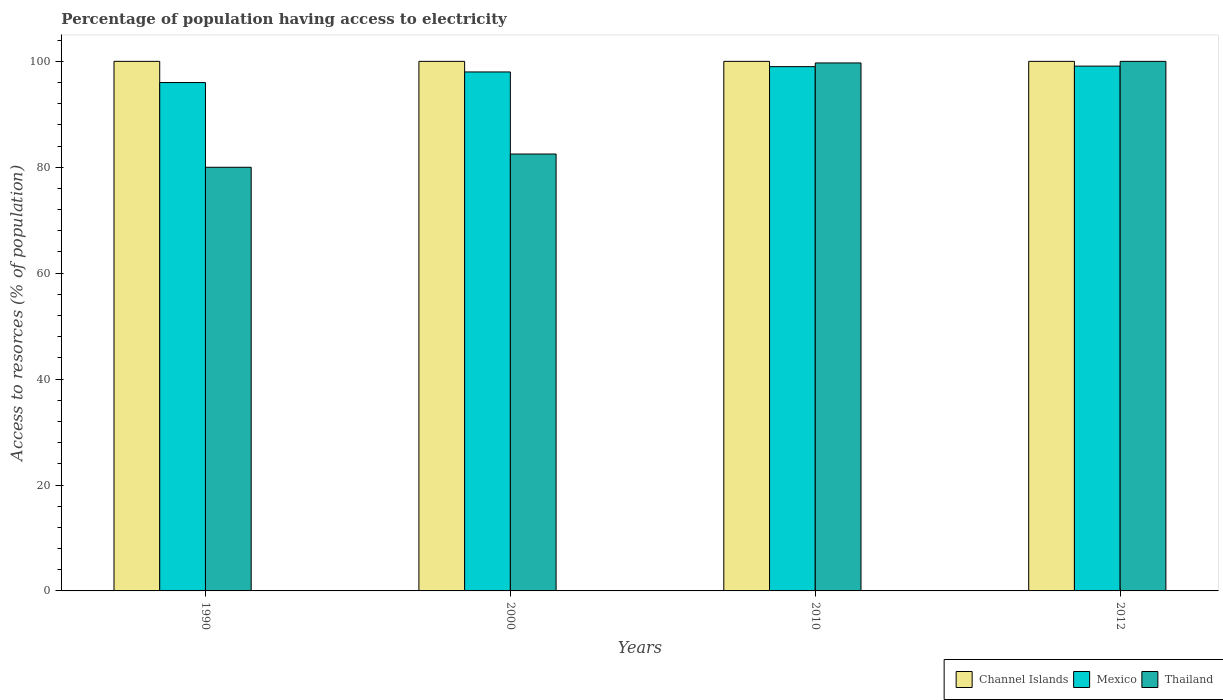Are the number of bars per tick equal to the number of legend labels?
Offer a very short reply. Yes. Are the number of bars on each tick of the X-axis equal?
Offer a very short reply. Yes. How many bars are there on the 1st tick from the left?
Your answer should be very brief. 3. What is the label of the 4th group of bars from the left?
Offer a very short reply. 2012. What is the percentage of population having access to electricity in Mexico in 2000?
Your response must be concise. 98. Across all years, what is the maximum percentage of population having access to electricity in Thailand?
Offer a very short reply. 100. Across all years, what is the minimum percentage of population having access to electricity in Channel Islands?
Provide a short and direct response. 100. In which year was the percentage of population having access to electricity in Mexico maximum?
Your answer should be very brief. 2012. In which year was the percentage of population having access to electricity in Channel Islands minimum?
Provide a short and direct response. 1990. What is the total percentage of population having access to electricity in Mexico in the graph?
Make the answer very short. 392.1. What is the difference between the percentage of population having access to electricity in Channel Islands in 2000 and the percentage of population having access to electricity in Thailand in 1990?
Offer a very short reply. 20. In the year 2010, what is the difference between the percentage of population having access to electricity in Channel Islands and percentage of population having access to electricity in Thailand?
Ensure brevity in your answer.  0.3. What is the ratio of the percentage of population having access to electricity in Thailand in 1990 to that in 2000?
Ensure brevity in your answer.  0.97. Is the percentage of population having access to electricity in Thailand in 1990 less than that in 2000?
Your answer should be very brief. Yes. Is the difference between the percentage of population having access to electricity in Channel Islands in 1990 and 2012 greater than the difference between the percentage of population having access to electricity in Thailand in 1990 and 2012?
Offer a terse response. Yes. What is the difference between the highest and the second highest percentage of population having access to electricity in Channel Islands?
Offer a terse response. 0. What is the difference between the highest and the lowest percentage of population having access to electricity in Channel Islands?
Your answer should be compact. 0. In how many years, is the percentage of population having access to electricity in Thailand greater than the average percentage of population having access to electricity in Thailand taken over all years?
Provide a short and direct response. 2. What does the 3rd bar from the left in 2000 represents?
Make the answer very short. Thailand. What does the 3rd bar from the right in 2000 represents?
Offer a terse response. Channel Islands. How many years are there in the graph?
Your answer should be compact. 4. What is the difference between two consecutive major ticks on the Y-axis?
Your response must be concise. 20. Are the values on the major ticks of Y-axis written in scientific E-notation?
Your response must be concise. No. Where does the legend appear in the graph?
Make the answer very short. Bottom right. How many legend labels are there?
Ensure brevity in your answer.  3. What is the title of the graph?
Make the answer very short. Percentage of population having access to electricity. What is the label or title of the X-axis?
Offer a terse response. Years. What is the label or title of the Y-axis?
Keep it short and to the point. Access to resorces (% of population). What is the Access to resorces (% of population) in Channel Islands in 1990?
Provide a succinct answer. 100. What is the Access to resorces (% of population) of Mexico in 1990?
Your answer should be very brief. 96. What is the Access to resorces (% of population) in Thailand in 1990?
Ensure brevity in your answer.  80. What is the Access to resorces (% of population) in Mexico in 2000?
Make the answer very short. 98. What is the Access to resorces (% of population) in Thailand in 2000?
Offer a very short reply. 82.5. What is the Access to resorces (% of population) in Channel Islands in 2010?
Keep it short and to the point. 100. What is the Access to resorces (% of population) of Thailand in 2010?
Give a very brief answer. 99.7. What is the Access to resorces (% of population) in Mexico in 2012?
Provide a short and direct response. 99.1. What is the Access to resorces (% of population) of Thailand in 2012?
Provide a short and direct response. 100. Across all years, what is the maximum Access to resorces (% of population) in Channel Islands?
Your answer should be compact. 100. Across all years, what is the maximum Access to resorces (% of population) in Mexico?
Your response must be concise. 99.1. Across all years, what is the minimum Access to resorces (% of population) of Channel Islands?
Provide a succinct answer. 100. Across all years, what is the minimum Access to resorces (% of population) of Mexico?
Offer a very short reply. 96. Across all years, what is the minimum Access to resorces (% of population) in Thailand?
Ensure brevity in your answer.  80. What is the total Access to resorces (% of population) in Mexico in the graph?
Provide a short and direct response. 392.1. What is the total Access to resorces (% of population) in Thailand in the graph?
Provide a succinct answer. 362.2. What is the difference between the Access to resorces (% of population) in Channel Islands in 1990 and that in 2000?
Your answer should be compact. 0. What is the difference between the Access to resorces (% of population) in Thailand in 1990 and that in 2000?
Keep it short and to the point. -2.5. What is the difference between the Access to resorces (% of population) in Thailand in 1990 and that in 2010?
Provide a succinct answer. -19.7. What is the difference between the Access to resorces (% of population) of Thailand in 1990 and that in 2012?
Your answer should be very brief. -20. What is the difference between the Access to resorces (% of population) of Thailand in 2000 and that in 2010?
Give a very brief answer. -17.2. What is the difference between the Access to resorces (% of population) in Channel Islands in 2000 and that in 2012?
Your answer should be very brief. 0. What is the difference between the Access to resorces (% of population) of Mexico in 2000 and that in 2012?
Offer a terse response. -1.1. What is the difference between the Access to resorces (% of population) in Thailand in 2000 and that in 2012?
Offer a very short reply. -17.5. What is the difference between the Access to resorces (% of population) in Mexico in 2010 and that in 2012?
Give a very brief answer. -0.1. What is the difference between the Access to resorces (% of population) of Thailand in 2010 and that in 2012?
Provide a succinct answer. -0.3. What is the difference between the Access to resorces (% of population) in Channel Islands in 1990 and the Access to resorces (% of population) in Thailand in 2010?
Offer a very short reply. 0.3. What is the difference between the Access to resorces (% of population) of Mexico in 1990 and the Access to resorces (% of population) of Thailand in 2010?
Your answer should be compact. -3.7. What is the difference between the Access to resorces (% of population) in Channel Islands in 2000 and the Access to resorces (% of population) in Mexico in 2010?
Offer a very short reply. 1. What is the difference between the Access to resorces (% of population) of Channel Islands in 2000 and the Access to resorces (% of population) of Thailand in 2010?
Your answer should be compact. 0.3. What is the difference between the Access to resorces (% of population) of Channel Islands in 2000 and the Access to resorces (% of population) of Thailand in 2012?
Provide a short and direct response. 0. What is the difference between the Access to resorces (% of population) in Channel Islands in 2010 and the Access to resorces (% of population) in Mexico in 2012?
Keep it short and to the point. 0.9. What is the difference between the Access to resorces (% of population) in Channel Islands in 2010 and the Access to resorces (% of population) in Thailand in 2012?
Your response must be concise. 0. What is the difference between the Access to resorces (% of population) of Mexico in 2010 and the Access to resorces (% of population) of Thailand in 2012?
Provide a short and direct response. -1. What is the average Access to resorces (% of population) in Mexico per year?
Provide a short and direct response. 98.03. What is the average Access to resorces (% of population) in Thailand per year?
Provide a succinct answer. 90.55. In the year 1990, what is the difference between the Access to resorces (% of population) of Channel Islands and Access to resorces (% of population) of Mexico?
Your response must be concise. 4. In the year 1990, what is the difference between the Access to resorces (% of population) of Channel Islands and Access to resorces (% of population) of Thailand?
Provide a succinct answer. 20. In the year 1990, what is the difference between the Access to resorces (% of population) in Mexico and Access to resorces (% of population) in Thailand?
Provide a short and direct response. 16. In the year 2000, what is the difference between the Access to resorces (% of population) in Channel Islands and Access to resorces (% of population) in Mexico?
Provide a succinct answer. 2. In the year 2000, what is the difference between the Access to resorces (% of population) in Mexico and Access to resorces (% of population) in Thailand?
Offer a very short reply. 15.5. In the year 2010, what is the difference between the Access to resorces (% of population) of Channel Islands and Access to resorces (% of population) of Thailand?
Provide a short and direct response. 0.3. In the year 2012, what is the difference between the Access to resorces (% of population) of Channel Islands and Access to resorces (% of population) of Mexico?
Give a very brief answer. 0.9. In the year 2012, what is the difference between the Access to resorces (% of population) of Channel Islands and Access to resorces (% of population) of Thailand?
Your response must be concise. 0. What is the ratio of the Access to resorces (% of population) of Channel Islands in 1990 to that in 2000?
Your answer should be very brief. 1. What is the ratio of the Access to resorces (% of population) in Mexico in 1990 to that in 2000?
Offer a very short reply. 0.98. What is the ratio of the Access to resorces (% of population) in Thailand in 1990 to that in 2000?
Make the answer very short. 0.97. What is the ratio of the Access to resorces (% of population) of Channel Islands in 1990 to that in 2010?
Keep it short and to the point. 1. What is the ratio of the Access to resorces (% of population) of Mexico in 1990 to that in 2010?
Your answer should be compact. 0.97. What is the ratio of the Access to resorces (% of population) of Thailand in 1990 to that in 2010?
Ensure brevity in your answer.  0.8. What is the ratio of the Access to resorces (% of population) in Channel Islands in 1990 to that in 2012?
Keep it short and to the point. 1. What is the ratio of the Access to resorces (% of population) of Mexico in 1990 to that in 2012?
Provide a succinct answer. 0.97. What is the ratio of the Access to resorces (% of population) of Thailand in 1990 to that in 2012?
Provide a succinct answer. 0.8. What is the ratio of the Access to resorces (% of population) of Mexico in 2000 to that in 2010?
Offer a terse response. 0.99. What is the ratio of the Access to resorces (% of population) of Thailand in 2000 to that in 2010?
Offer a terse response. 0.83. What is the ratio of the Access to resorces (% of population) in Mexico in 2000 to that in 2012?
Your response must be concise. 0.99. What is the ratio of the Access to resorces (% of population) in Thailand in 2000 to that in 2012?
Provide a succinct answer. 0.82. What is the difference between the highest and the second highest Access to resorces (% of population) of Channel Islands?
Offer a very short reply. 0. What is the difference between the highest and the second highest Access to resorces (% of population) in Mexico?
Offer a terse response. 0.1. What is the difference between the highest and the second highest Access to resorces (% of population) in Thailand?
Offer a very short reply. 0.3. What is the difference between the highest and the lowest Access to resorces (% of population) of Channel Islands?
Keep it short and to the point. 0. 